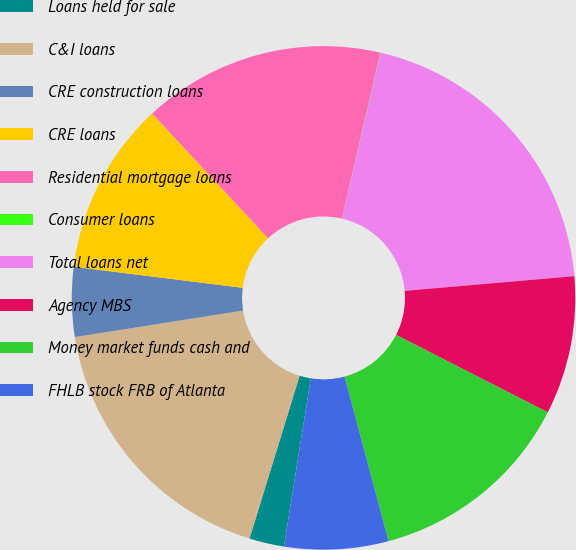Convert chart to OTSL. <chart><loc_0><loc_0><loc_500><loc_500><pie_chart><fcel>Loans held for sale<fcel>C&I loans<fcel>CRE construction loans<fcel>CRE loans<fcel>Residential mortgage loans<fcel>Consumer loans<fcel>Total loans net<fcel>Agency MBS<fcel>Money market funds cash and<fcel>FHLB stock FRB of Atlanta<nl><fcel>2.24%<fcel>17.76%<fcel>4.46%<fcel>11.11%<fcel>15.54%<fcel>0.02%<fcel>19.98%<fcel>8.89%<fcel>13.33%<fcel>6.67%<nl></chart> 